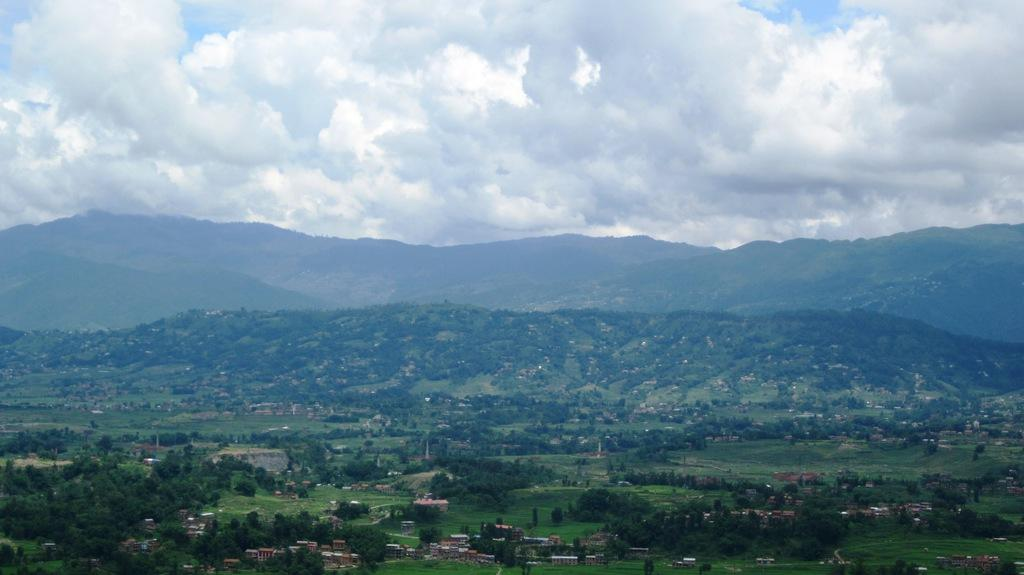What type of view is shown in the image? The image is an outside view. What can be seen at the bottom of the image? There are many buildings and trees at the bottom of the image. What geographical features are present in the middle of the image? There are hills in the middle of the image. What is visible at the top of the image? The sky is visible at the top of the image. What can be observed in the sky? Clouds are present in the sky. What type of bells can be heard ringing in the image? There are no bells present in the image, and therefore no sound can be heard. Can you describe the woman walking through the hills in the image? There is no woman present in the image; it only features buildings, trees, hills, and clouds. 